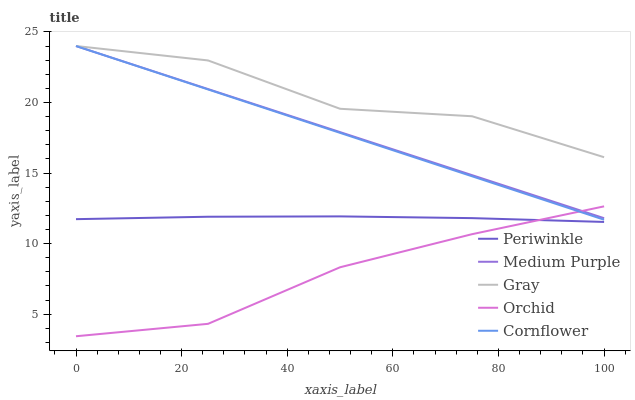Does Orchid have the minimum area under the curve?
Answer yes or no. Yes. Does Gray have the maximum area under the curve?
Answer yes or no. Yes. Does Periwinkle have the minimum area under the curve?
Answer yes or no. No. Does Periwinkle have the maximum area under the curve?
Answer yes or no. No. Is Medium Purple the smoothest?
Answer yes or no. Yes. Is Gray the roughest?
Answer yes or no. Yes. Is Periwinkle the smoothest?
Answer yes or no. No. Is Periwinkle the roughest?
Answer yes or no. No. Does Orchid have the lowest value?
Answer yes or no. Yes. Does Periwinkle have the lowest value?
Answer yes or no. No. Does Cornflower have the highest value?
Answer yes or no. Yes. Does Periwinkle have the highest value?
Answer yes or no. No. Is Periwinkle less than Gray?
Answer yes or no. Yes. Is Gray greater than Orchid?
Answer yes or no. Yes. Does Orchid intersect Medium Purple?
Answer yes or no. Yes. Is Orchid less than Medium Purple?
Answer yes or no. No. Is Orchid greater than Medium Purple?
Answer yes or no. No. Does Periwinkle intersect Gray?
Answer yes or no. No. 